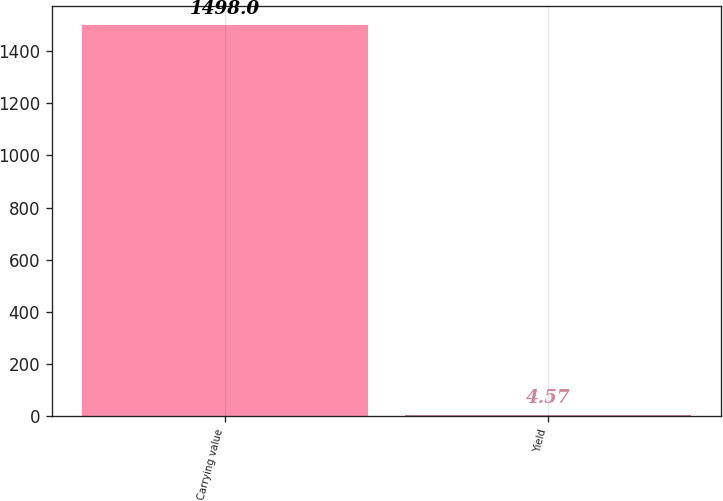<chart> <loc_0><loc_0><loc_500><loc_500><bar_chart><fcel>Carrying value<fcel>Yield<nl><fcel>1498<fcel>4.57<nl></chart> 